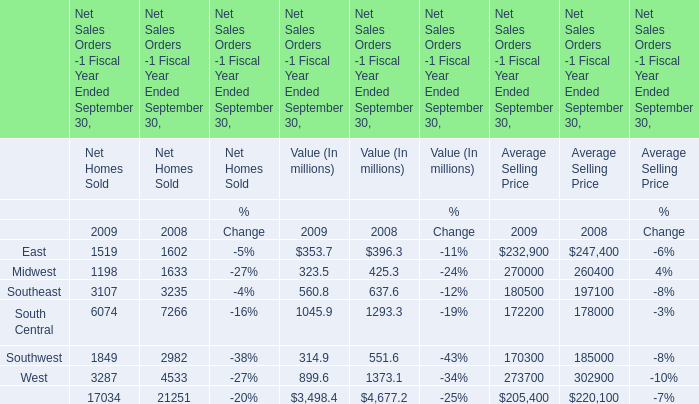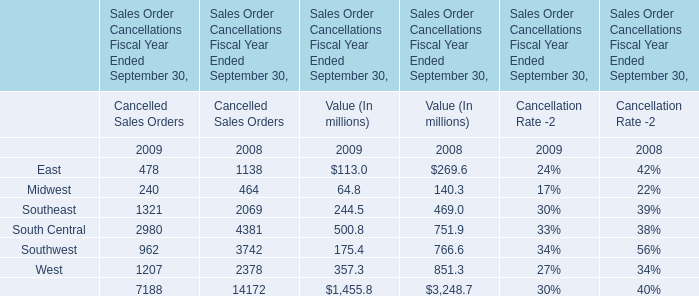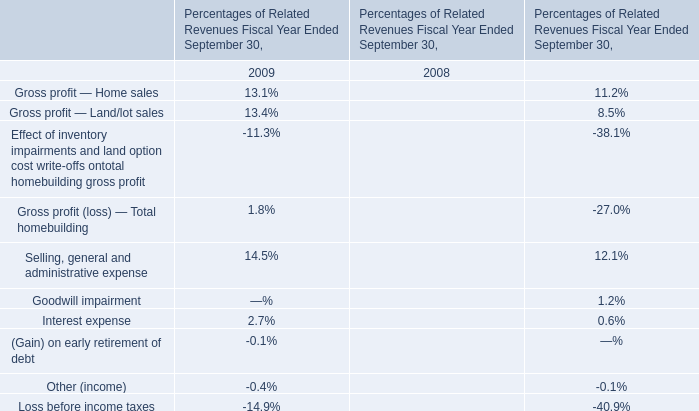What is the proportion of East for Net Homes Sold to the total in 2009 ? 
Computations: (1519 / 17034)
Answer: 0.08917. 